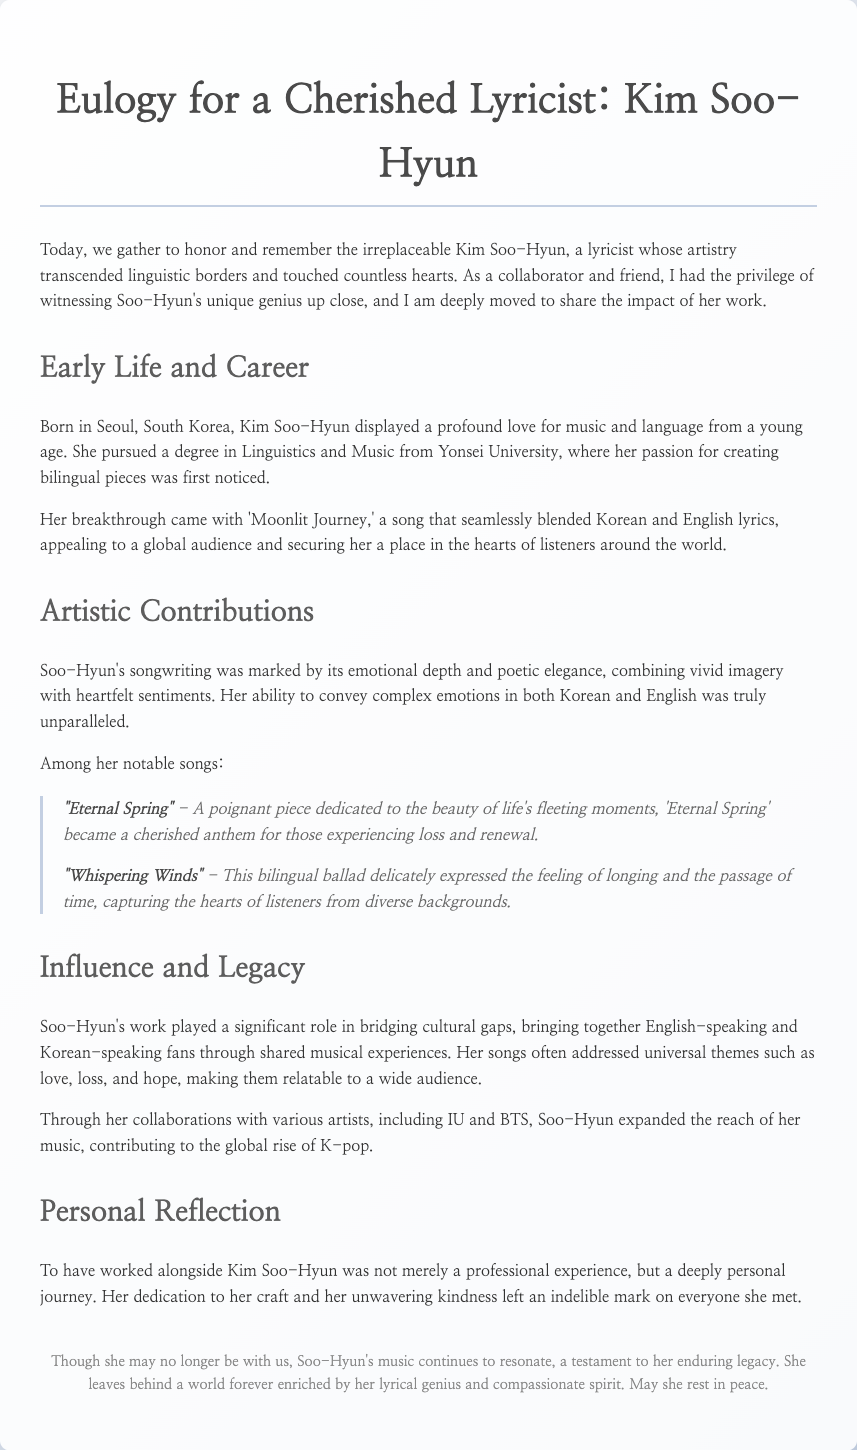What is the name of the lyricist being honored? The document is a eulogy for Kim Soo-Hyun, a cherished lyricist.
Answer: Kim Soo-Hyun What was Kim Soo-Hyun's breakthrough song? The breakthrough song that brought her recognition was 'Moonlit Journey.'
Answer: Moonlit Journey What degree did Kim Soo-Hyun pursue? She pursued a degree in Linguistics and Music at Yonsei University.
Answer: Linguistics and Music Which song represents themes of loss and renewal? The song 'Eternal Spring' is dedicated to the beauty of life's fleeting moments and addresses themes of loss and renewal.
Answer: Eternal Spring Which artists did Kim Soo-Hyun collaborate with? Kim Soo-Hyun collaborated with various artists, including IU and BTS.
Answer: IU and BTS What is the primary emotional theme of Kim Soo-Hyun's lyrics? Her songs often addressed universal themes such as love, loss, and hope.
Answer: Love, loss, hope How did Kim Soo-Hyun's work impact cultural gaps? Her music played a significant role in bridging cultural gaps between English-speaking and Korean-speaking fans.
Answer: Bridging cultural gaps What is the overall tone of the eulogy? The tone of the eulogy is deeply touching and reflective of admiration for Kim Soo-Hyun's contributions.
Answer: Deeply touching 